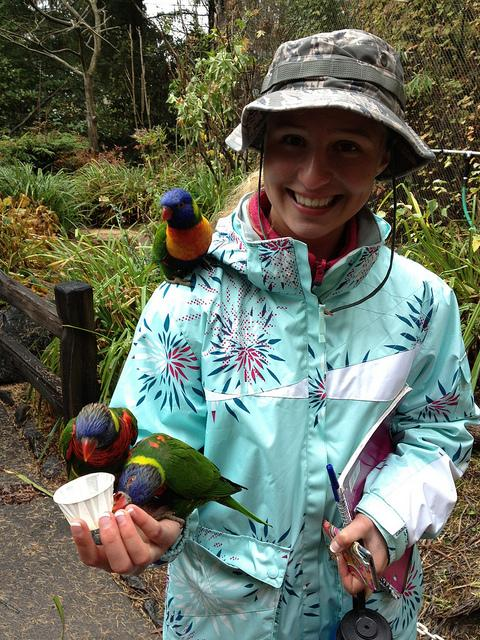What color is the rain jacket worn by the woman in the rainforest? Please explain your reasoning. teal. Her rainjacket is not purple, red, or orange. 